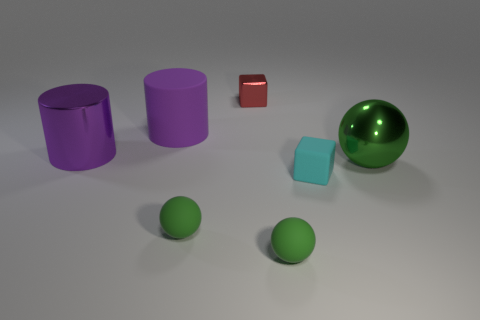How many things are either green balls that are behind the tiny rubber cube or tiny cyan objects?
Your answer should be compact. 2. Do the cyan rubber cube and the metal block have the same size?
Offer a very short reply. Yes. What color is the large metal object that is to the right of the red cube?
Give a very brief answer. Green. There is a cylinder that is the same material as the small cyan cube; what is its size?
Offer a terse response. Large. There is a matte block; is its size the same as the cube that is behind the large ball?
Offer a terse response. Yes. There is a sphere behind the tiny matte block; what is its material?
Keep it short and to the point. Metal. There is a large cylinder that is in front of the purple rubber cylinder; how many tiny cyan rubber blocks are in front of it?
Offer a terse response. 1. Is there another green thing that has the same shape as the large green metallic object?
Give a very brief answer. Yes. Is the size of the purple cylinder that is to the left of the big matte cylinder the same as the block in front of the big green object?
Your answer should be very brief. No. What shape is the tiny green matte thing left of the tiny cube behind the large green metal ball?
Your answer should be very brief. Sphere. 